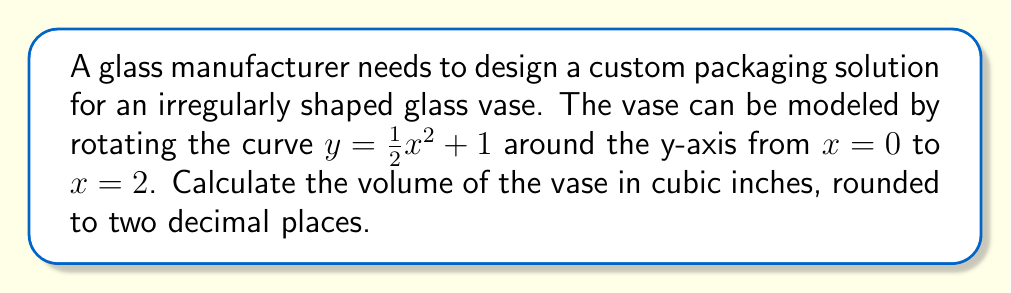Can you answer this question? To calculate the volume of this irregularly shaped glass vase, we need to use the method of integration in 3D space, specifically the shell method for volumes of revolution.

1. The shell method formula for volume is:

   $$V = 2\pi \int_a^b x f(x) dx$$

   where $x$ is the radius of each cylindrical shell and $f(x)$ is the height of the shell.

2. In this case, $f(x) = \frac{1}{2}x^2 + 1$, $a = 0$, and $b = 2$.

3. Substituting these into our formula:

   $$V = 2\pi \int_0^2 x (\frac{1}{2}x^2 + 1) dx$$

4. Expand the integrand:

   $$V = 2\pi \int_0^2 (\frac{1}{2}x^3 + x) dx$$

5. Integrate:

   $$V = 2\pi [\frac{1}{8}x^4 + \frac{1}{2}x^2]_0^2$$

6. Evaluate the definite integral:

   $$V = 2\pi [(\frac{1}{8}(2^4) + \frac{1}{2}(2^2)) - (\frac{1}{8}(0^4) + \frac{1}{2}(0^2))]$$
   $$V = 2\pi [(\frac{16}{8} + 2) - 0]$$
   $$V = 2\pi [4]$$
   $$V = 8\pi$$

7. Calculate the final value and round to two decimal places:

   $$V \approx 25.13 \text{ cubic inches}$$
Answer: 25.13 cubic inches 